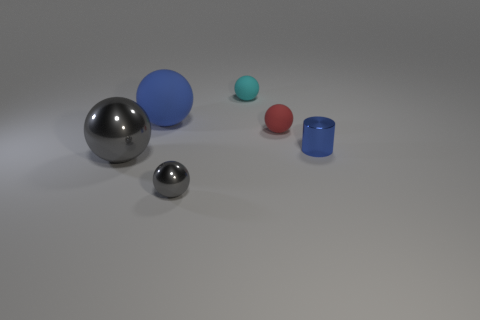Is the number of tiny red rubber spheres that are to the left of the big blue object less than the number of small gray metallic spheres that are right of the small cylinder?
Keep it short and to the point. No. Are there any other things that are the same shape as the small blue thing?
Your answer should be compact. No. Do the large metal object and the large blue rubber object have the same shape?
Give a very brief answer. Yes. The blue sphere is what size?
Make the answer very short. Large. What color is the sphere that is both behind the metallic cylinder and in front of the large blue object?
Make the answer very short. Red. Is the number of gray spheres greater than the number of red rubber objects?
Make the answer very short. Yes. What number of things are either metal cylinders or tiny objects that are left of the cylinder?
Provide a short and direct response. 4. Do the cyan ball and the blue sphere have the same size?
Keep it short and to the point. No. There is a cylinder; are there any small matte things in front of it?
Ensure brevity in your answer.  No. How big is the object that is both on the right side of the small cyan matte sphere and behind the shiny cylinder?
Your answer should be very brief. Small. 